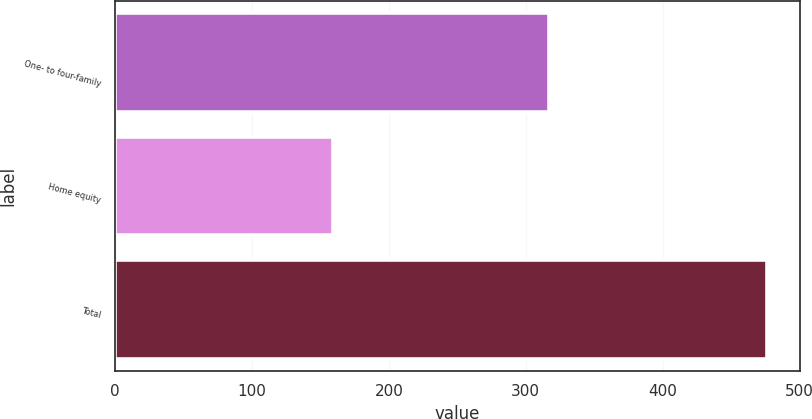Convert chart to OTSL. <chart><loc_0><loc_0><loc_500><loc_500><bar_chart><fcel>One- to four-family<fcel>Home equity<fcel>Total<nl><fcel>317.1<fcel>159.2<fcel>476.3<nl></chart> 